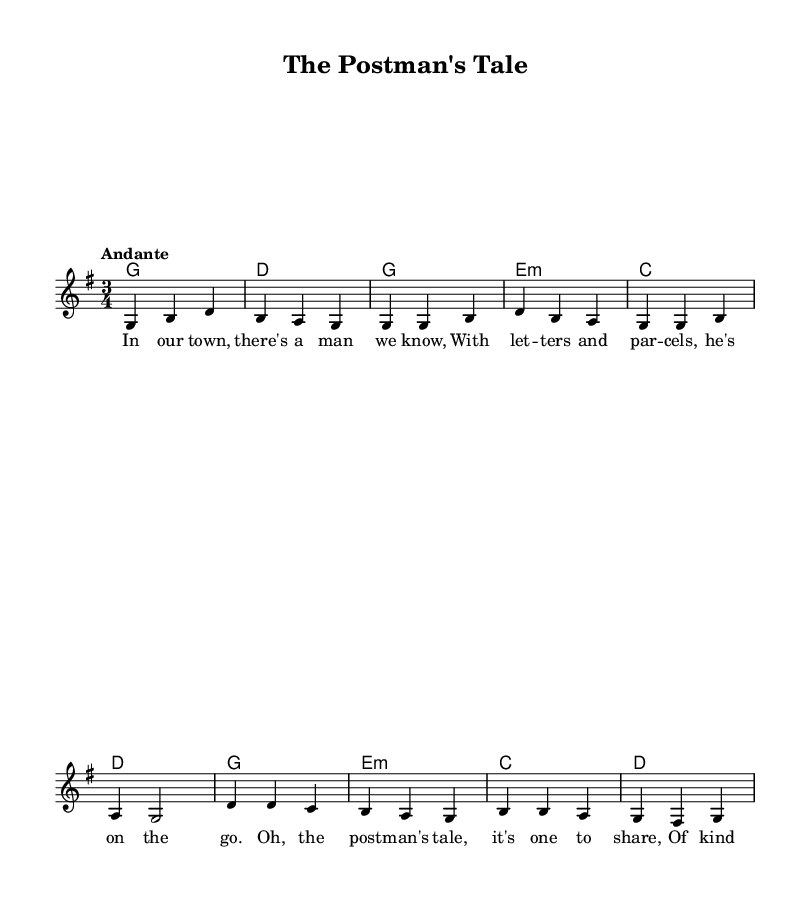What is the key signature of this music? The key signature indicates that the piece is in G major, which has one sharp (F#). This can be identified by examining the key signature at the beginning of the staff.
Answer: G major What is the time signature of this music? The time signature is 3/4, as indicated at the beginning of the sheet music. This means there are three beats in each measure and a quarter note receives one beat.
Answer: 3/4 What is the tempo marking for this piece? The tempo marking "Andante" suggests a moderate speed, typically around 76-108 beats per minute. This is directly stated in the tempo indication above the staff.
Answer: Andante How many measures are in the first verse? To find the number of measures, we count each vertical line separating the sections in the melody for verse one, which starts from the first note until the end of the verse. There are four measures in the first verse section shown.
Answer: Four What musical form does this piece primarily follow? The piece follows a verse-chorus form since it has a distinct verse ("In our town...") and a chorus ("Oh, the postman’s tale...") that repeats. This can be determined by observing the structure of the lyrics associated with the music.
Answer: Verse-Chorus Which instrument is primarily featured in this score? The score features a lead voice for the melody, which is indicated by the new Voice line labeled "lead." Thus, the primary instrument for this score is the voice, although it can also be accompanied by chords for harmony.
Answer: Voice What theme is expressed in the lyrics of the song? The theme in the lyrics revolves around local kindness and heroism as they describe a postman who serves the community. This can be deduced by analyzing the content of the lyrics provided in the score.
Answer: Kindness and service 